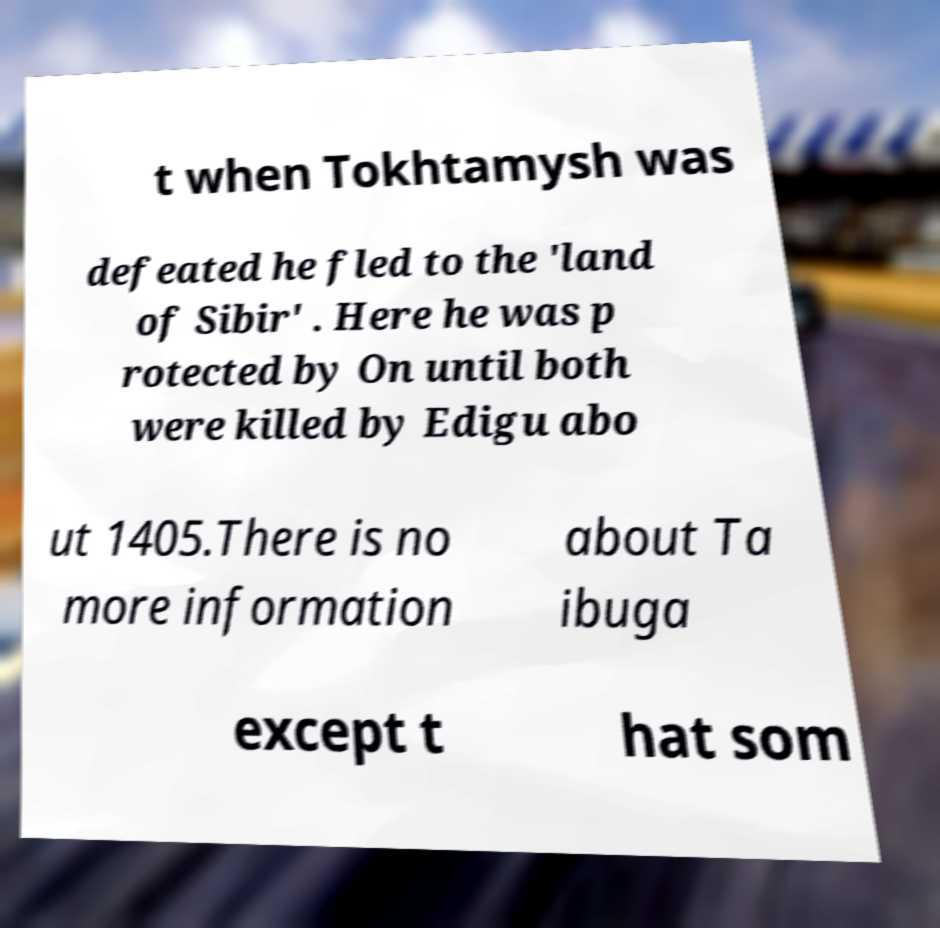For documentation purposes, I need the text within this image transcribed. Could you provide that? t when Tokhtamysh was defeated he fled to the 'land of Sibir' . Here he was p rotected by On until both were killed by Edigu abo ut 1405.There is no more information about Ta ibuga except t hat som 